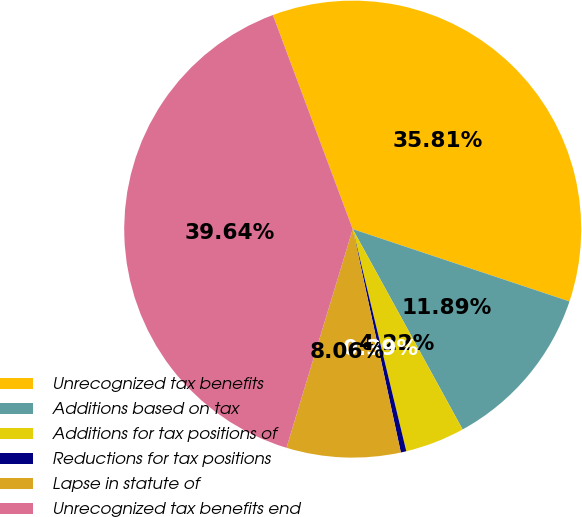Convert chart to OTSL. <chart><loc_0><loc_0><loc_500><loc_500><pie_chart><fcel>Unrecognized tax benefits<fcel>Additions based on tax<fcel>Additions for tax positions of<fcel>Reductions for tax positions<fcel>Lapse in statute of<fcel>Unrecognized tax benefits end<nl><fcel>35.81%<fcel>11.89%<fcel>4.22%<fcel>0.39%<fcel>8.06%<fcel>39.64%<nl></chart> 